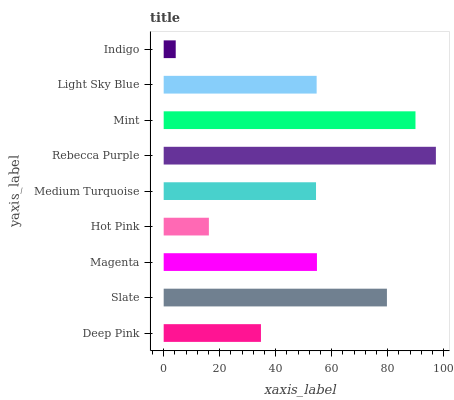Is Indigo the minimum?
Answer yes or no. Yes. Is Rebecca Purple the maximum?
Answer yes or no. Yes. Is Slate the minimum?
Answer yes or no. No. Is Slate the maximum?
Answer yes or no. No. Is Slate greater than Deep Pink?
Answer yes or no. Yes. Is Deep Pink less than Slate?
Answer yes or no. Yes. Is Deep Pink greater than Slate?
Answer yes or no. No. Is Slate less than Deep Pink?
Answer yes or no. No. Is Light Sky Blue the high median?
Answer yes or no. Yes. Is Light Sky Blue the low median?
Answer yes or no. Yes. Is Indigo the high median?
Answer yes or no. No. Is Rebecca Purple the low median?
Answer yes or no. No. 